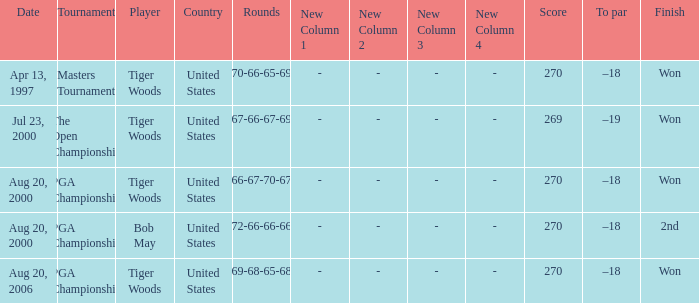What days were the rounds of 66-67-70-67 recorded? Aug 20, 2000. 